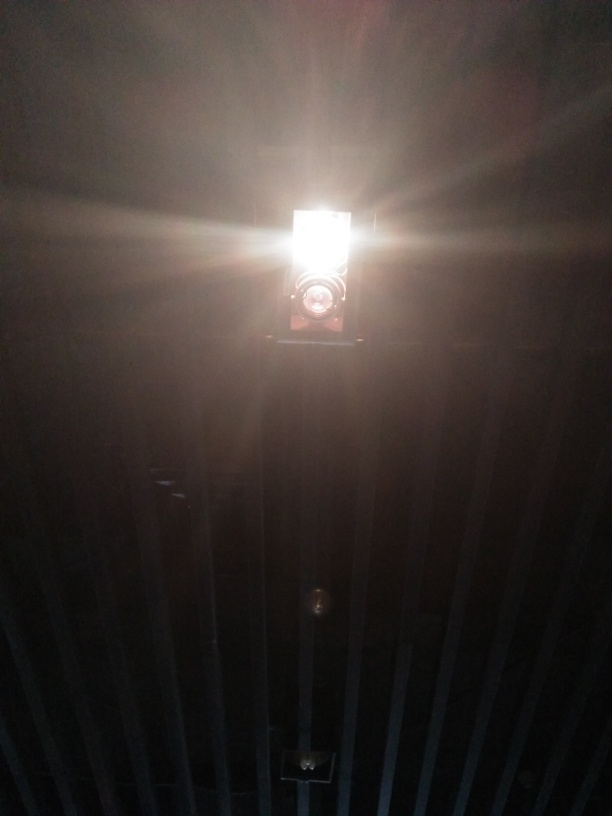What can you tell about the light source in the image? The light source appears to be directly facing the camera, causing overexposure in the center of the image. It looks like a strong, artificial light, possibly from a ceiling-mounted fixture. 